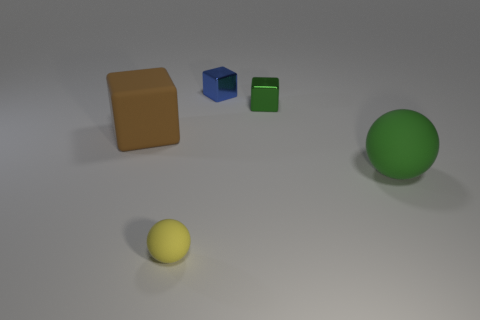What size is the yellow matte thing?
Your response must be concise. Small. There is a small shiny thing on the right side of the blue block; does it have the same color as the large sphere?
Your response must be concise. Yes. Are there any large rubber things to the left of the big green matte thing?
Your answer should be very brief. Yes. What color is the cube that is in front of the blue object and to the left of the green cube?
Make the answer very short. Brown. There is a metallic thing that is the same color as the big matte sphere; what is its shape?
Ensure brevity in your answer.  Cube. There is a matte object behind the big matte object right of the big brown rubber cube; what size is it?
Your response must be concise. Large. How many balls are tiny matte objects or large brown objects?
Your response must be concise. 1. The other shiny block that is the same size as the blue cube is what color?
Your answer should be very brief. Green. The large rubber object that is behind the big matte sphere in front of the brown matte object is what shape?
Your response must be concise. Cube. There is a metal cube on the right side of the blue object; does it have the same size as the small matte ball?
Offer a terse response. Yes. 